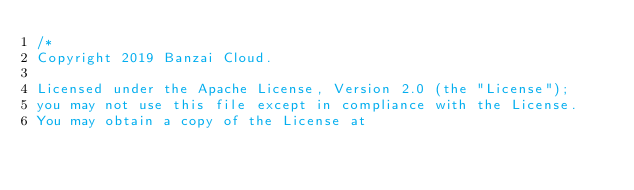Convert code to text. <code><loc_0><loc_0><loc_500><loc_500><_Go_>/*
Copyright 2019 Banzai Cloud.

Licensed under the Apache License, Version 2.0 (the "License");
you may not use this file except in compliance with the License.
You may obtain a copy of the License at
</code> 